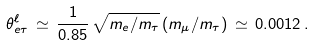<formula> <loc_0><loc_0><loc_500><loc_500>\theta _ { e \tau } ^ { \ell } \, \simeq \, \frac { 1 } { 0 . 8 5 } \, \sqrt { m _ { e } / m _ { \tau } } \, ( m _ { \mu } / m _ { \tau } ) \, \simeq \, 0 . 0 0 1 2 \, .</formula> 